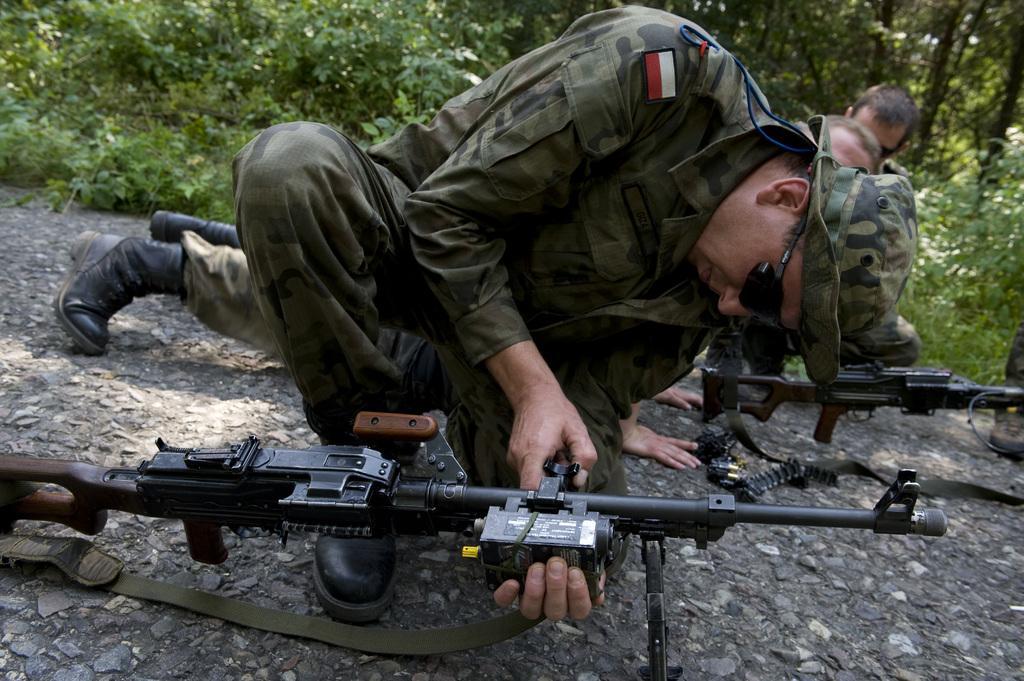Describe this image in one or two sentences. In the center of the image there are people and weapons. In the background of the image there are trees and plants. At the bottom of the image there is stone surface. 